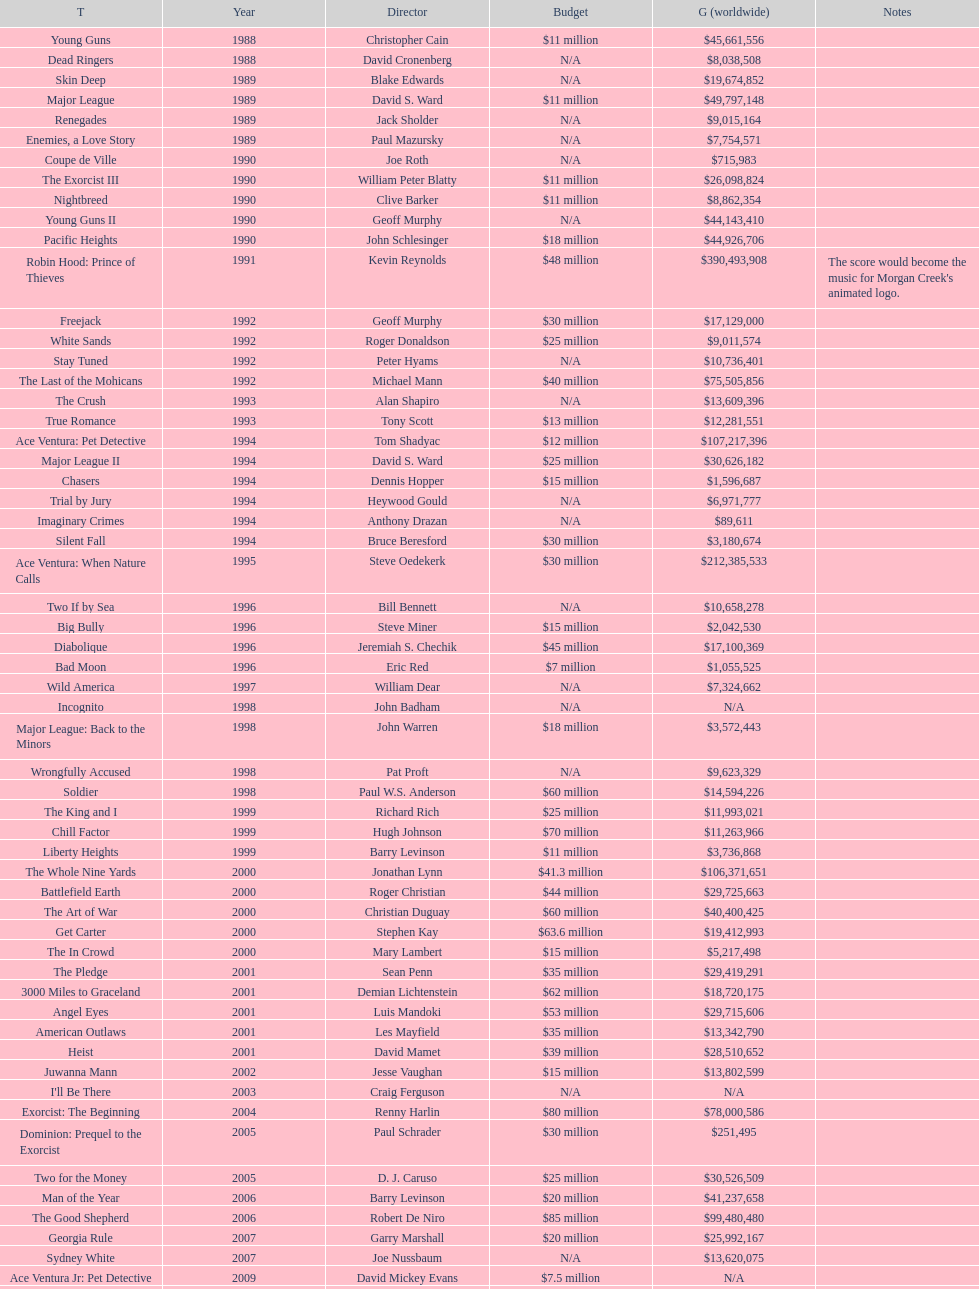What was the subsequent movie with the same budget as young guns? Major League. 